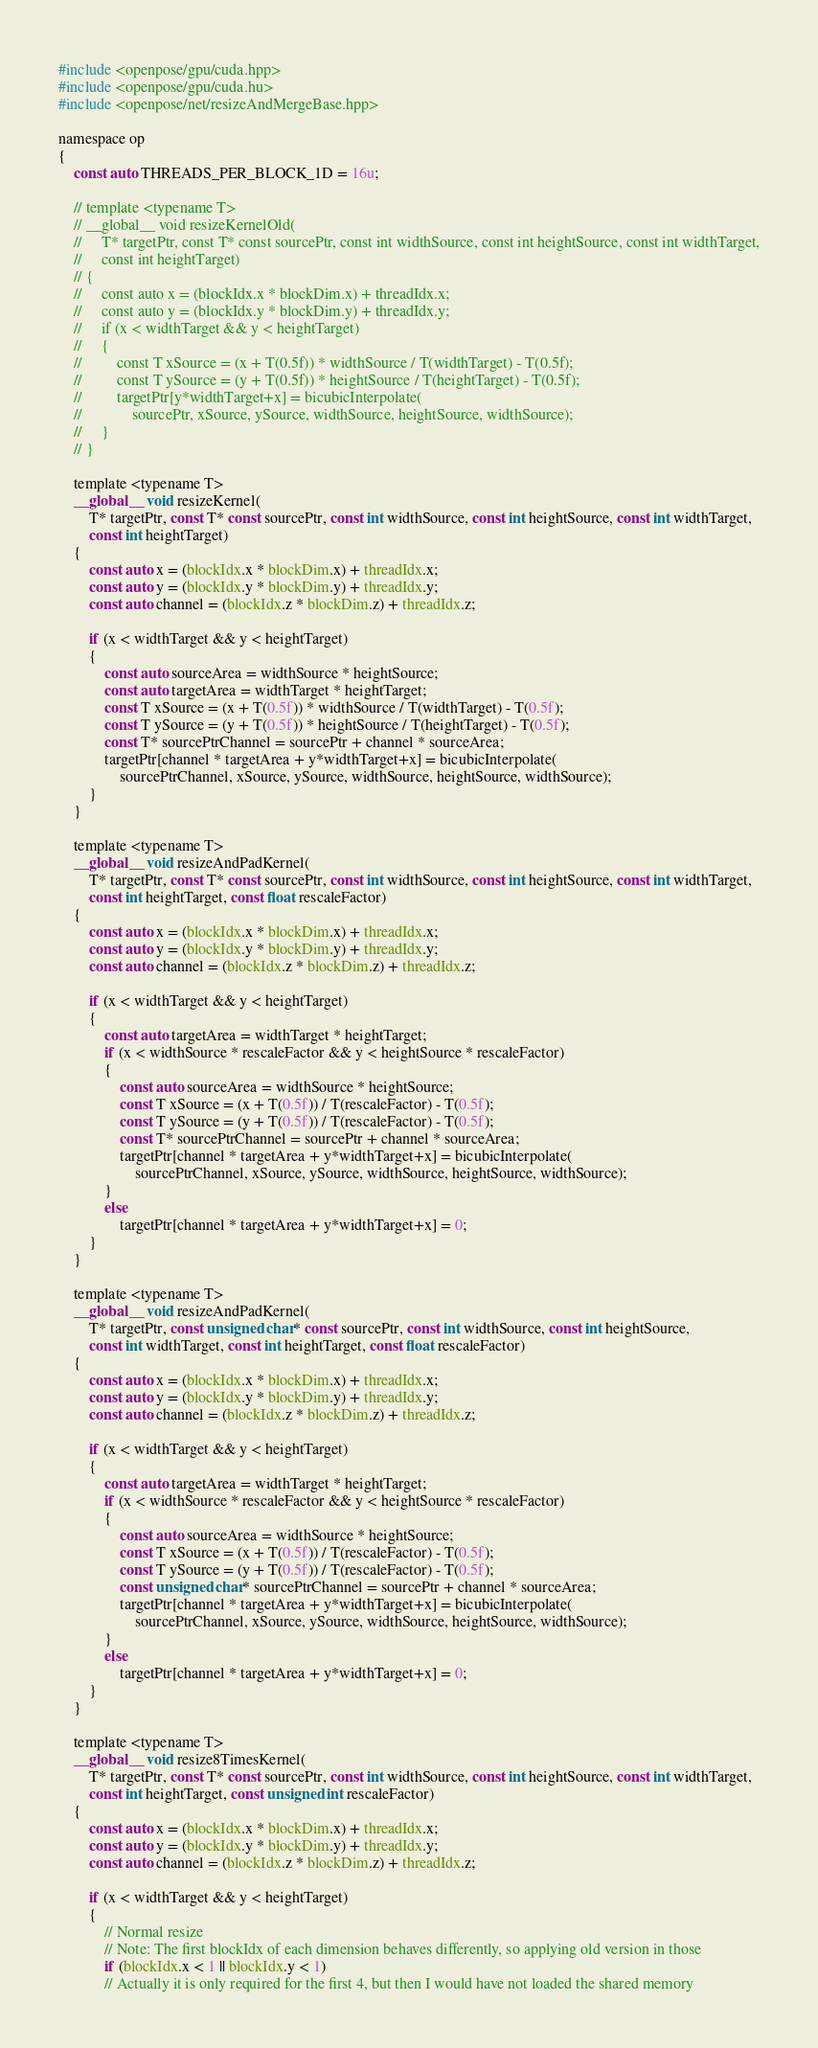<code> <loc_0><loc_0><loc_500><loc_500><_Cuda_>#include <openpose/gpu/cuda.hpp>
#include <openpose/gpu/cuda.hu>
#include <openpose/net/resizeAndMergeBase.hpp>

namespace op
{
    const auto THREADS_PER_BLOCK_1D = 16u;

    // template <typename T>
    // __global__ void resizeKernelOld(
    //     T* targetPtr, const T* const sourcePtr, const int widthSource, const int heightSource, const int widthTarget,
    //     const int heightTarget)
    // {
    //     const auto x = (blockIdx.x * blockDim.x) + threadIdx.x;
    //     const auto y = (blockIdx.y * blockDim.y) + threadIdx.y;
    //     if (x < widthTarget && y < heightTarget)
    //     {
    //         const T xSource = (x + T(0.5f)) * widthSource / T(widthTarget) - T(0.5f);
    //         const T ySource = (y + T(0.5f)) * heightSource / T(heightTarget) - T(0.5f);
    //         targetPtr[y*widthTarget+x] = bicubicInterpolate(
    //             sourcePtr, xSource, ySource, widthSource, heightSource, widthSource);
    //     }
    // }

    template <typename T>
    __global__ void resizeKernel(
        T* targetPtr, const T* const sourcePtr, const int widthSource, const int heightSource, const int widthTarget,
        const int heightTarget)
    {
        const auto x = (blockIdx.x * blockDim.x) + threadIdx.x;
        const auto y = (blockIdx.y * blockDim.y) + threadIdx.y;
        const auto channel = (blockIdx.z * blockDim.z) + threadIdx.z;

        if (x < widthTarget && y < heightTarget)
        {
            const auto sourceArea = widthSource * heightSource;
            const auto targetArea = widthTarget * heightTarget;
            const T xSource = (x + T(0.5f)) * widthSource / T(widthTarget) - T(0.5f);
            const T ySource = (y + T(0.5f)) * heightSource / T(heightTarget) - T(0.5f);
            const T* sourcePtrChannel = sourcePtr + channel * sourceArea;
            targetPtr[channel * targetArea + y*widthTarget+x] = bicubicInterpolate(
                sourcePtrChannel, xSource, ySource, widthSource, heightSource, widthSource);
        }
    }

    template <typename T>
    __global__ void resizeAndPadKernel(
        T* targetPtr, const T* const sourcePtr, const int widthSource, const int heightSource, const int widthTarget,
        const int heightTarget, const float rescaleFactor)
    {
        const auto x = (blockIdx.x * blockDim.x) + threadIdx.x;
        const auto y = (blockIdx.y * blockDim.y) + threadIdx.y;
        const auto channel = (blockIdx.z * blockDim.z) + threadIdx.z;

        if (x < widthTarget && y < heightTarget)
        {
            const auto targetArea = widthTarget * heightTarget;
            if (x < widthSource * rescaleFactor && y < heightSource * rescaleFactor)
            {
                const auto sourceArea = widthSource * heightSource;
                const T xSource = (x + T(0.5f)) / T(rescaleFactor) - T(0.5f);
                const T ySource = (y + T(0.5f)) / T(rescaleFactor) - T(0.5f);
                const T* sourcePtrChannel = sourcePtr + channel * sourceArea;
                targetPtr[channel * targetArea + y*widthTarget+x] = bicubicInterpolate(
                    sourcePtrChannel, xSource, ySource, widthSource, heightSource, widthSource);
            }
            else
                targetPtr[channel * targetArea + y*widthTarget+x] = 0;
        }
    }

    template <typename T>
    __global__ void resizeAndPadKernel(
        T* targetPtr, const unsigned char* const sourcePtr, const int widthSource, const int heightSource,
        const int widthTarget, const int heightTarget, const float rescaleFactor)
    {
        const auto x = (blockIdx.x * blockDim.x) + threadIdx.x;
        const auto y = (blockIdx.y * blockDim.y) + threadIdx.y;
        const auto channel = (blockIdx.z * blockDim.z) + threadIdx.z;

        if (x < widthTarget && y < heightTarget)
        {
            const auto targetArea = widthTarget * heightTarget;
            if (x < widthSource * rescaleFactor && y < heightSource * rescaleFactor)
            {
                const auto sourceArea = widthSource * heightSource;
                const T xSource = (x + T(0.5f)) / T(rescaleFactor) - T(0.5f);
                const T ySource = (y + T(0.5f)) / T(rescaleFactor) - T(0.5f);
                const unsigned char* sourcePtrChannel = sourcePtr + channel * sourceArea;
                targetPtr[channel * targetArea + y*widthTarget+x] = bicubicInterpolate(
                    sourcePtrChannel, xSource, ySource, widthSource, heightSource, widthSource);
            }
            else
                targetPtr[channel * targetArea + y*widthTarget+x] = 0;
        }
    }

    template <typename T>
    __global__ void resize8TimesKernel(
        T* targetPtr, const T* const sourcePtr, const int widthSource, const int heightSource, const int widthTarget,
        const int heightTarget, const unsigned int rescaleFactor)
    {
        const auto x = (blockIdx.x * blockDim.x) + threadIdx.x;
        const auto y = (blockIdx.y * blockDim.y) + threadIdx.y;
        const auto channel = (blockIdx.z * blockDim.z) + threadIdx.z;

        if (x < widthTarget && y < heightTarget)
        {
            // Normal resize
            // Note: The first blockIdx of each dimension behaves differently, so applying old version in those
            if (blockIdx.x < 1 || blockIdx.y < 1)
            // Actually it is only required for the first 4, but then I would have not loaded the shared memory</code> 